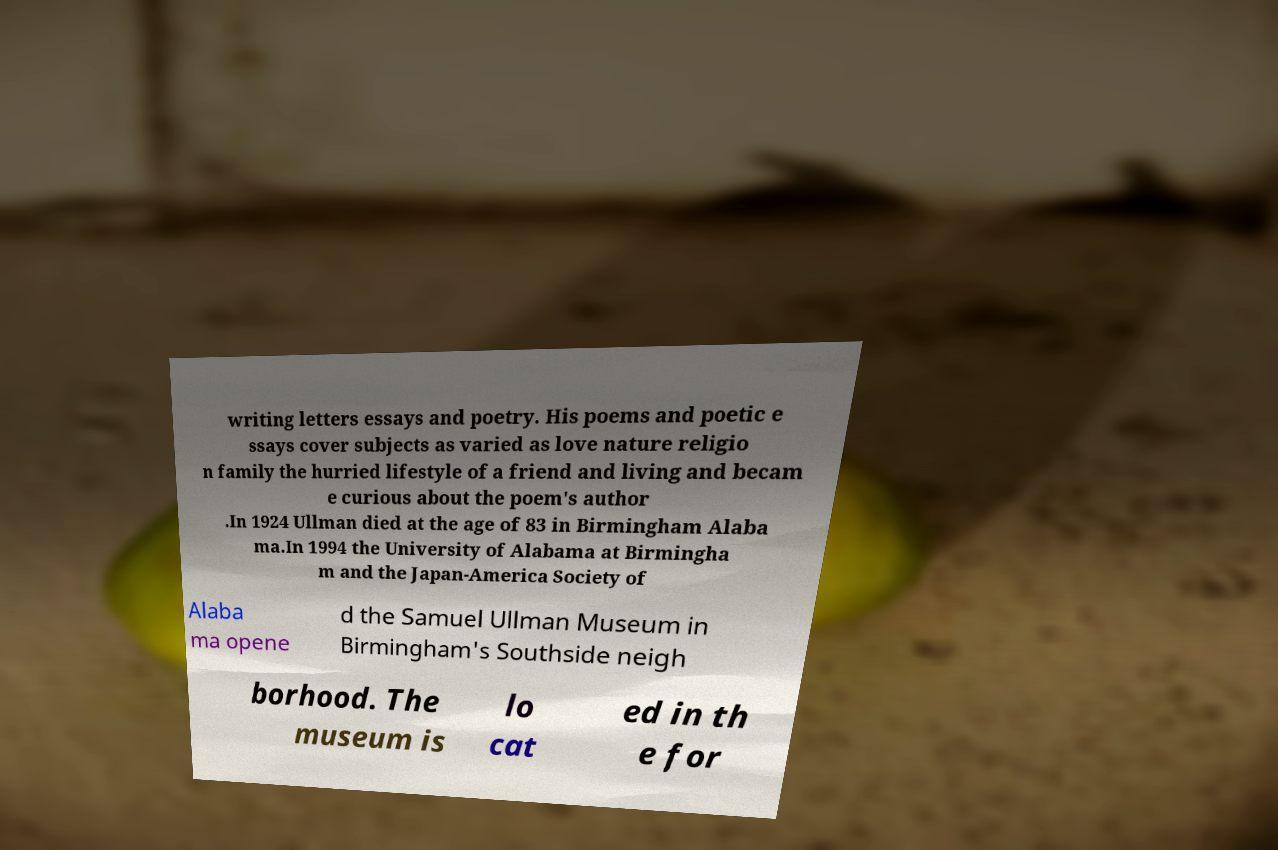What messages or text are displayed in this image? I need them in a readable, typed format. writing letters essays and poetry. His poems and poetic e ssays cover subjects as varied as love nature religio n family the hurried lifestyle of a friend and living and becam e curious about the poem's author .In 1924 Ullman died at the age of 83 in Birmingham Alaba ma.In 1994 the University of Alabama at Birmingha m and the Japan-America Society of Alaba ma opene d the Samuel Ullman Museum in Birmingham's Southside neigh borhood. The museum is lo cat ed in th e for 